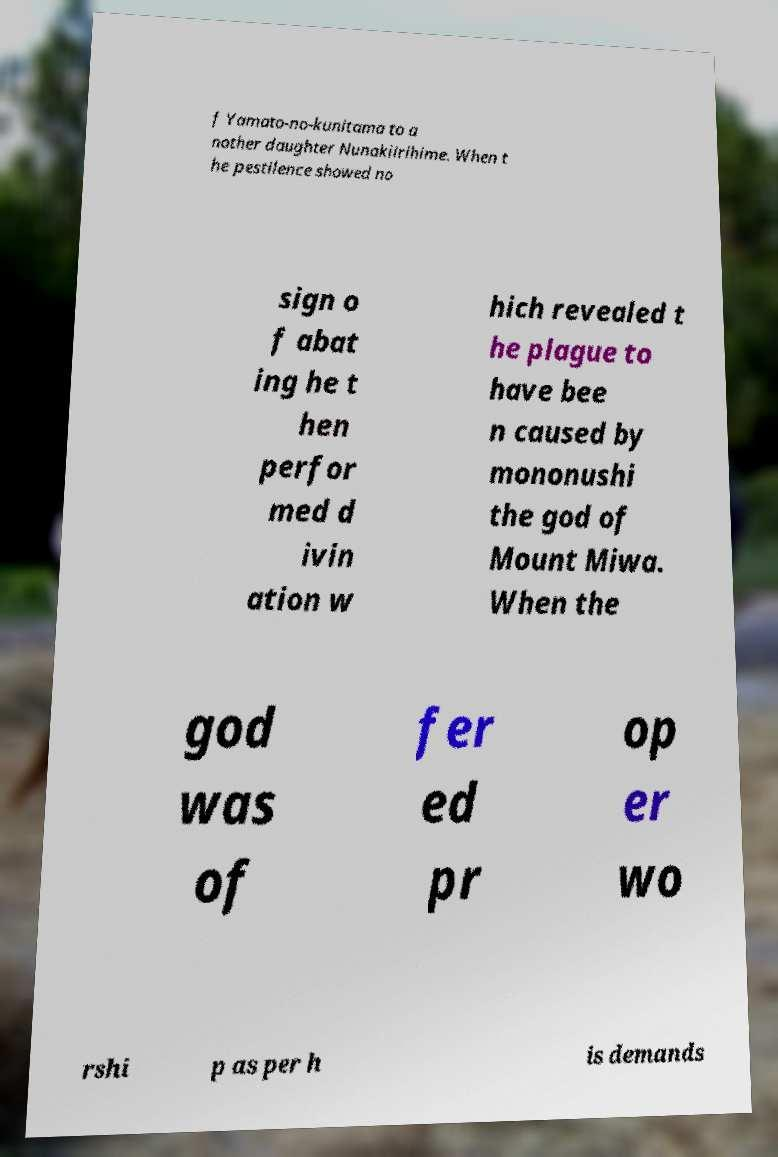Can you accurately transcribe the text from the provided image for me? f Yamato-no-kunitama to a nother daughter Nunakiirihime. When t he pestilence showed no sign o f abat ing he t hen perfor med d ivin ation w hich revealed t he plague to have bee n caused by mononushi the god of Mount Miwa. When the god was of fer ed pr op er wo rshi p as per h is demands 